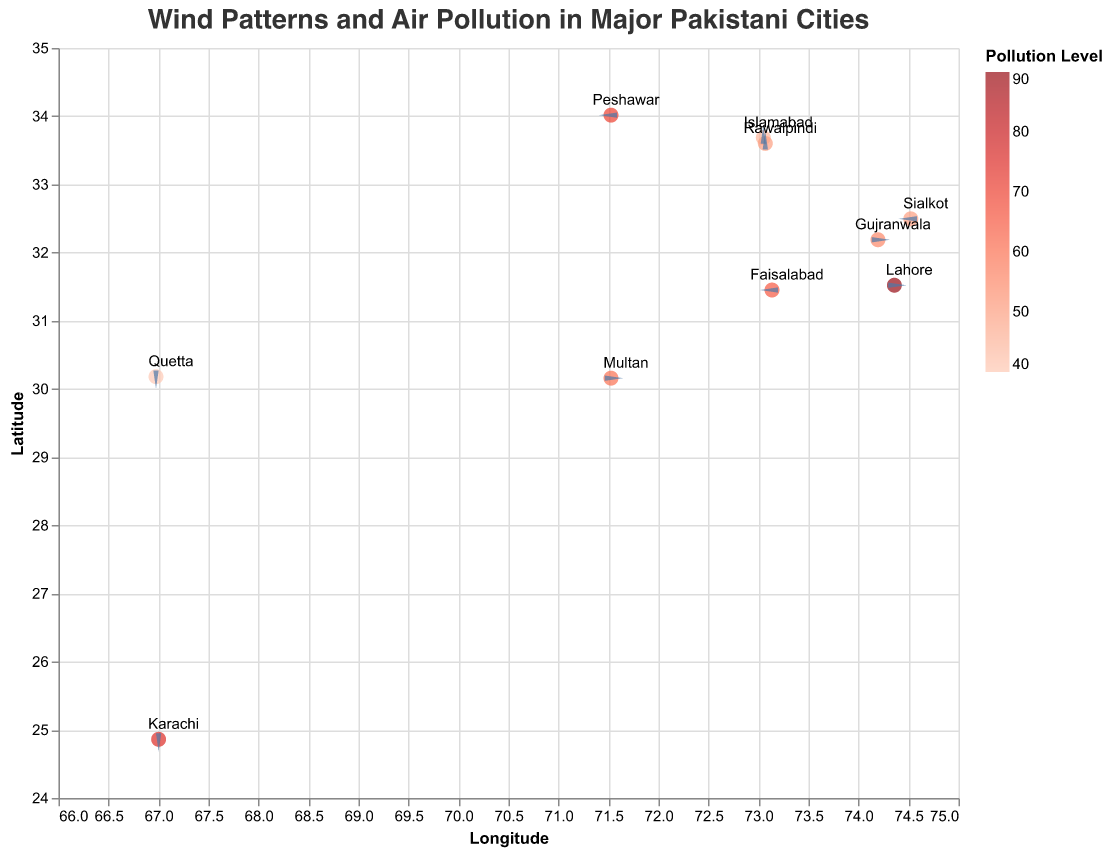What's the highest air pollution level and which city does it belong to? By looking at the color legend and the size of the circles, the darkest circle represents the highest pollution level. The tooltip indicates that Lahore has the highest pollution level at 90.
Answer: Lahore, 90 Which city has the cleanest (least polluted) air? By inspecting the color legend and the size of the circles, the lightest circle represents the lowest pollution level. The tooltip signifies that Quetta has the lowest pollution level at 40.
Answer: Quetta, 40 How does the wind direction in Quetta compare to that in Karachi? By examining the direction and angle of the wedge shapes at the respective coordinates for Quetta and Karachi, Quetta has a wind direction vector of (2, -1), pointing southeast, while Karachi has a wind direction vector of (-2, 1), pointing northwest.
Answer: Quetta: southeast, Karachi: northwest What is the average air pollution level across all cities? Sum the pollution levels of all cities and then divide by the number of cities. (75 + 90 + 45 + 65 + 50 + 60 + 70 + 40 + 55 + 50) / 10 = 60.
Answer: 60 Which cities have northerly wind components (positive Wind_Direction_Y)? Northerly wind components correspond to cities where Wind_Direction_Y is positive. These cities are Karachi, Islamabad, Rawalpindi, Multan, Gujranwala, and Sialkot.
Answer: Karachi, Islamabad, Rawalpindi, Multan, Gujranwala, Sialkot Compare the wind patterns between Islamabad and Rawalpindi. Are they similar or different? Both Islamabad and Rawalpindi have the same wind direction vector of (0, 2), indicating they have similar wind patterns pointing north.
Answer: Similar What's the sum of air pollution levels for the cities with a westerly wind component (positive Wind_Direction_X)? Identify cities with positive Wind_Direction_X values: Lahore, Multan, Quetta, Gujranwala. Sum their pollution levels: 90 + 60 + 40 + 55 = 245.
Answer: 245 Which city has the strongest southerly wind component (most negative Wind_Direction_Y)? To find the strongest southerly component, look for the most negative Wind_Direction_Y value. Lahore has the most negative value at -1.
Answer: Lahore 